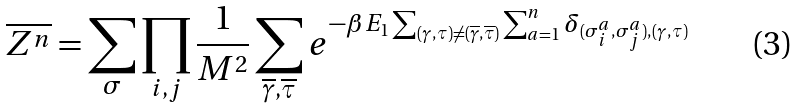Convert formula to latex. <formula><loc_0><loc_0><loc_500><loc_500>\overline { Z ^ { n } } = \sum _ { \sigma } \prod _ { i , j } \frac { 1 } { M ^ { 2 } } \sum _ { \overline { \gamma } , \overline { \tau } } e ^ { - \beta E _ { 1 } \sum _ { ( \gamma , \tau ) \neq ( \overline { \gamma } , \overline { \tau } ) } \sum _ { a = 1 } ^ { n } \delta _ { ( \sigma _ { i } ^ { a } , \sigma _ { j } ^ { a } ) , ( \gamma , \tau ) } }</formula> 